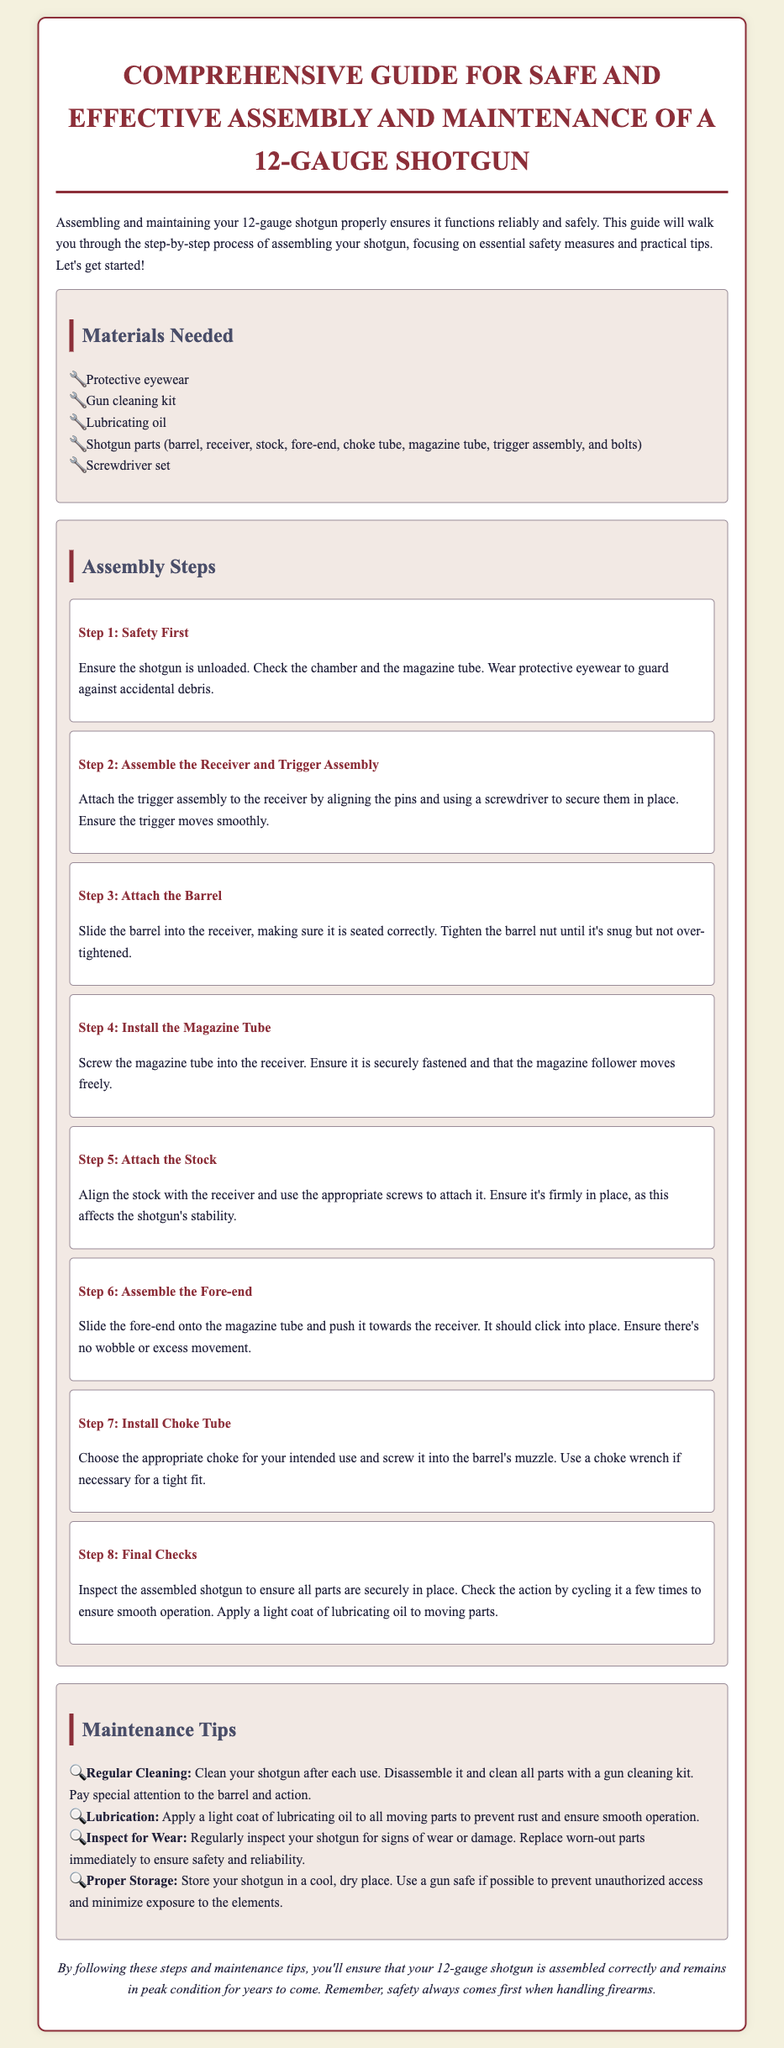What materials are needed for assembly? The materials list includes protective eyewear, gun cleaning kit, lubricating oil, shotgun parts, and screwdriver set.
Answer: Protective eyewear, gun cleaning kit, lubricating oil, shotgun parts, screwdriver set What is the first step in the assembly process? The first step is to ensure the shotgun is unloaded, check the chamber and magazine tube, and wear protective eyewear.
Answer: Safety First How many steps are there for assembly? The assembly section includes eight distinct steps as outlined in the document.
Answer: Eight What should you do to prevent rust on moving parts? The document suggests applying a light coat of lubricating oil to all moving parts.
Answer: Apply lubricating oil What is the recommended action after each use of the shotgun? The maintenance tips recommend cleaning the shotgun after each use by disassembling it and cleaning all parts.
Answer: Regular Cleaning What does the conclusion emphasize about firearm handling? The conclusion emphasizes the importance of prioritizing safety when handling firearms.
Answer: Safety always comes first 